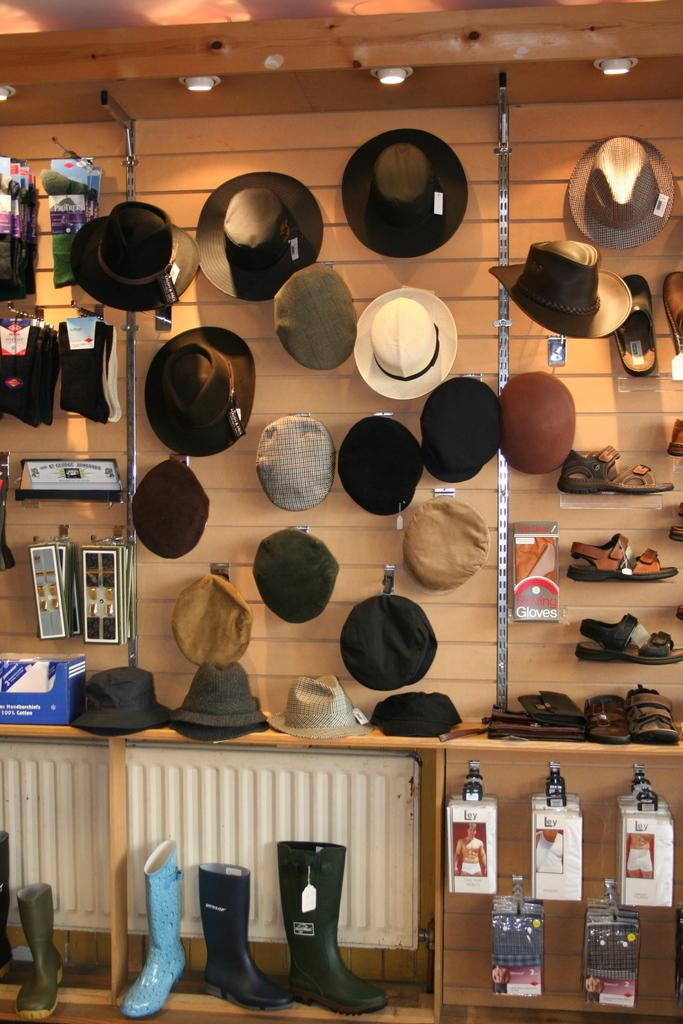What items can be seen in the foreground area of the image? There are hats, socks, and boots in the foreground area of the image. What objects are located at the top side of the image? There are lamps at the top side of the image. How many ministers are present in the image? There are no ministers present in the image. What theory is being discussed in the image? There is no discussion or mention of any theory in the image. 